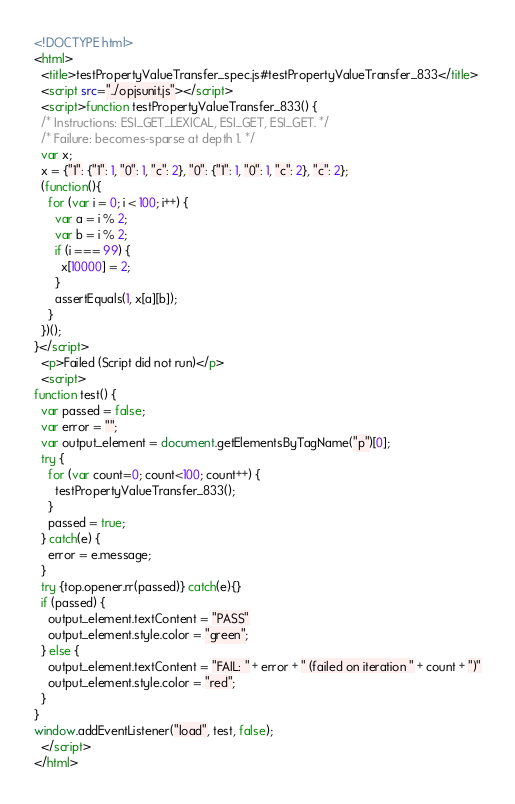Convert code to text. <code><loc_0><loc_0><loc_500><loc_500><_HTML_><!DOCTYPE html>
<html>
  <title>testPropertyValueTransfer_spec.js#testPropertyValueTransfer_833</title>
  <script src="../opjsunit.js"></script>
  <script>function testPropertyValueTransfer_833() {
  /* Instructions: ESI_GET_LEXICAL, ESI_GET, ESI_GET. */
  /* Failure: becomes-sparse at depth 1. */
  var x;
  x = {"1": {"1": 1, "0": 1, "c": 2}, "0": {"1": 1, "0": 1, "c": 2}, "c": 2};
  (function(){
    for (var i = 0; i < 100; i++) {
      var a = i % 2;
      var b = i % 2;
      if (i === 99) {
        x[10000] = 2;
      }
      assertEquals(1, x[a][b]);
    }
  })();
}</script>
  <p>Failed (Script did not run)</p>
  <script>
function test() {
  var passed = false;
  var error = "";
  var output_element = document.getElementsByTagName("p")[0];
  try {
    for (var count=0; count<100; count++) {
      testPropertyValueTransfer_833();
    }
    passed = true;
  } catch(e) {
    error = e.message;
  }
  try {top.opener.rr(passed)} catch(e){}
  if (passed) {
    output_element.textContent = "PASS"
    output_element.style.color = "green";
  } else {
    output_element.textContent = "FAIL: " + error + " (failed on iteration " + count + ")"
    output_element.style.color = "red";
  }
}
window.addEventListener("load", test, false);
  </script>
</html></code> 